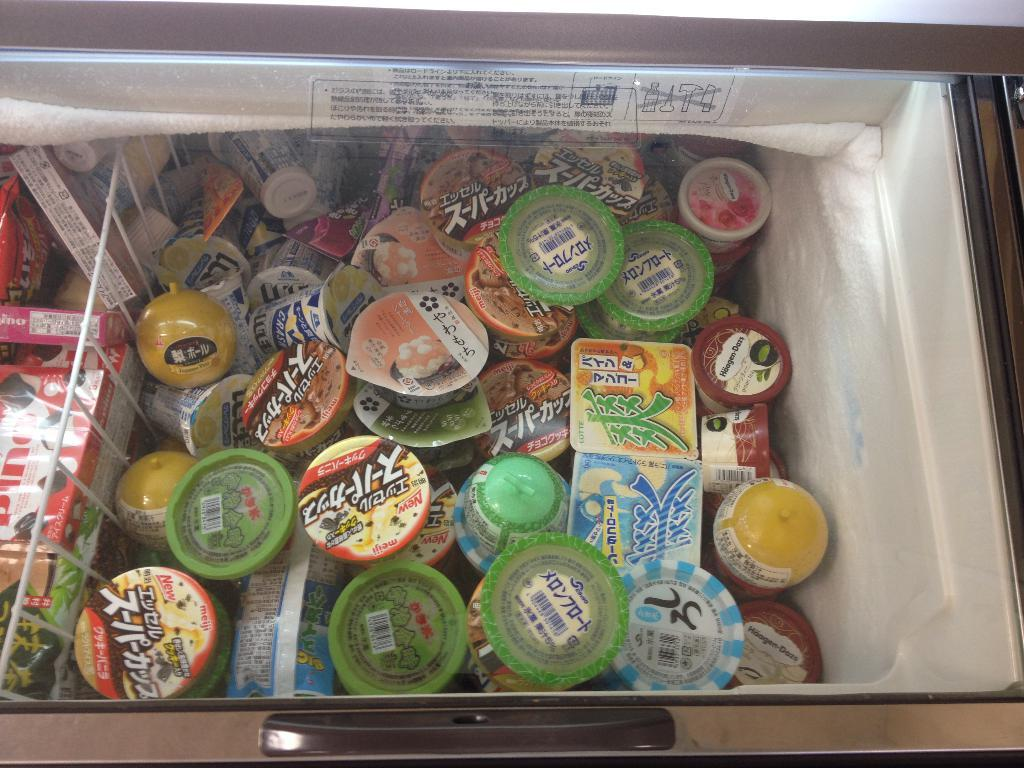What type of containers are visible in the image? There are cups in the image. What else can be seen in the image besides the cups? There are other objects in the image. How are the cups and objects arranged in the image? The cups and objects are separated with a rack. Where are the cups and objects located in the image? The cups and objects are placed in a fridge. What verse can be heard recited by the fly in the image? There is no fly present in the image, and therefore no verse can be heard. What type of learning is taking place in the image? There is no learning activity depicted in the image. 